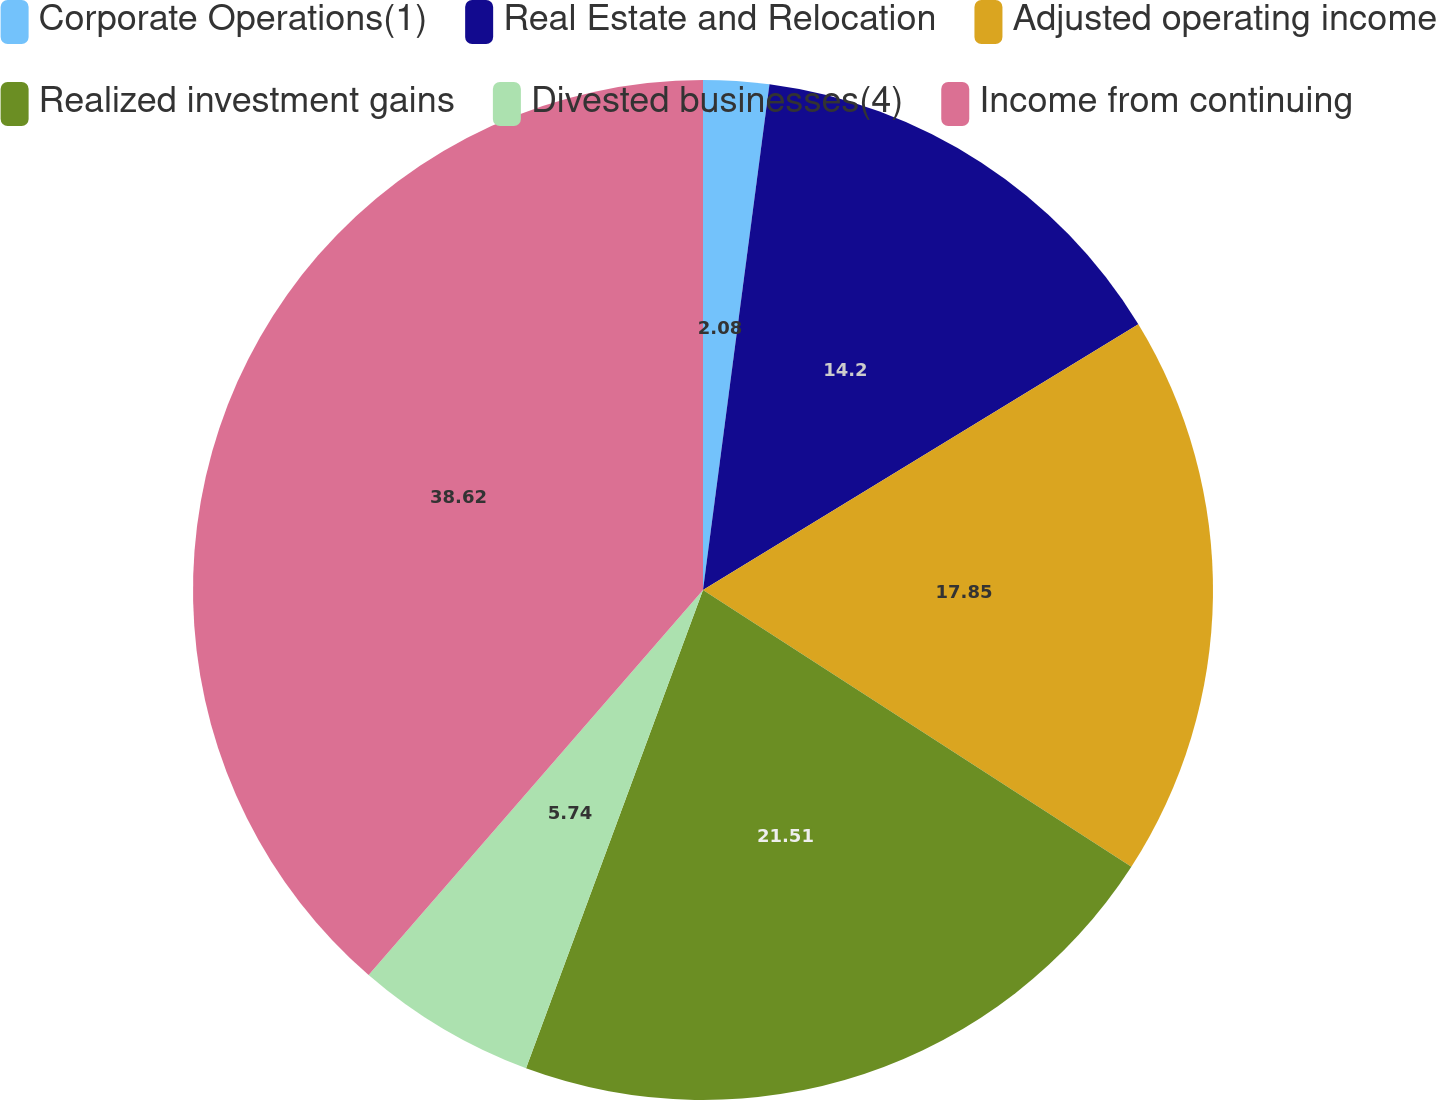<chart> <loc_0><loc_0><loc_500><loc_500><pie_chart><fcel>Corporate Operations(1)<fcel>Real Estate and Relocation<fcel>Adjusted operating income<fcel>Realized investment gains<fcel>Divested businesses(4)<fcel>Income from continuing<nl><fcel>2.08%<fcel>14.2%<fcel>17.85%<fcel>21.51%<fcel>5.74%<fcel>38.62%<nl></chart> 